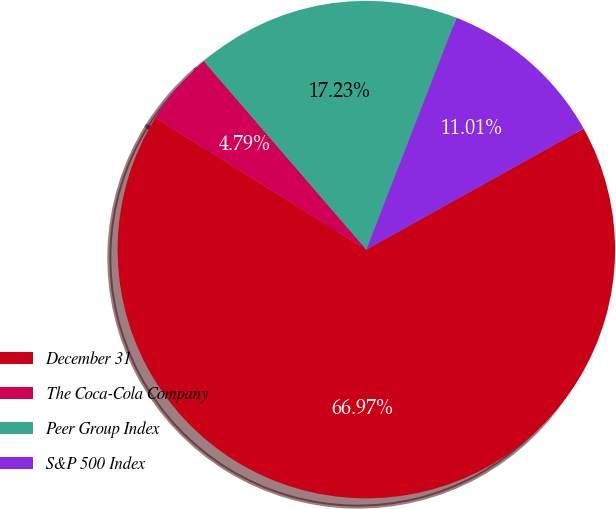Convert chart. <chart><loc_0><loc_0><loc_500><loc_500><pie_chart><fcel>December 31<fcel>The Coca-Cola Company<fcel>Peer Group Index<fcel>S&P 500 Index<nl><fcel>66.98%<fcel>4.79%<fcel>17.23%<fcel>11.01%<nl></chart> 